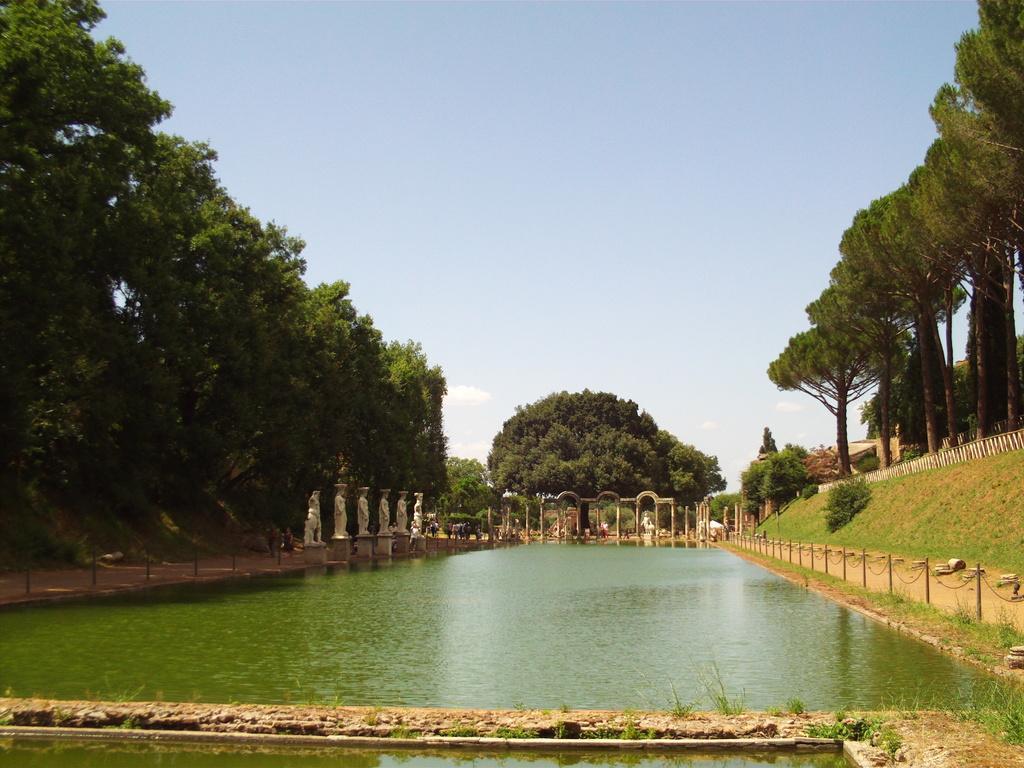How would you summarize this image in a sentence or two? In the picture we can see a water which is green in color and around it we can see grass surface and railing and behind it, we can see some trees and in the background also we can see some trees and sky. 